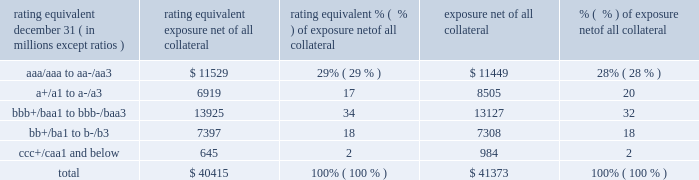Jpmorgan chase & co./2017 annual report 115 impact of wrong-way risk , which is broadly defined as the potential for increased correlation between the firm 2019s exposure to a counterparty ( avg ) and the counterparty 2019s credit quality .
Many factors may influence the nature and magnitude of these correlations over time .
To the extent that these correlations are identified , the firm may adjust the cva associated with that counterparty 2019s avg .
The firm risk manages exposure to changes in cva by entering into credit derivative transactions , as well as interest rate , foreign exchange , equity and commodity derivative transactions .
The accompanying graph shows exposure profiles to the firm 2019s current derivatives portfolio over the next 10 years as calculated by the peak , dre and avg metrics .
The three measures generally show that exposure will decline after the first year , if no new trades are added to the portfolio .
Exposure profile of derivatives measures december 31 , 2017 ( in billions ) the table summarizes the ratings profile by derivative counterparty of the firm 2019s derivative receivables , including credit derivatives , net of all collateral , at the dates indicated .
The ratings scale is based on the firm 2019s internal ratings , which generally correspond to the ratings as assigned by s&p and moody 2019s .
Ratings profile of derivative receivables .
As previously noted , the firm uses collateral agreements to mitigate counterparty credit risk .
The percentage of the firm 2019s over-the-counter derivatives transactions subject to collateral agreements 2014 excluding foreign exchange spot trades , which are not typically covered by collateral agreements due to their short maturity and centrally cleared trades that are settled daily 2014 was approximately 90% ( 90 % ) as of december 31 , 2017 , largely unchanged compared with december 31 , 2016 .
Credit derivatives the firm uses credit derivatives for two primary purposes : first , in its capacity as a market-maker , and second , as an end-user to manage the firm 2019s own credit risk associated with various exposures .
For a detailed description of credit derivatives , see credit derivatives in note 5 .
Credit portfolio management activities included in the firm 2019s end-user activities are credit derivatives used to mitigate the credit risk associated with traditional lending activities ( loans and unfunded commitments ) and derivatives counterparty exposure in the firm 2019s wholesale businesses ( collectively , 201ccredit portfolio management 201d activities ) .
Information on credit portfolio management activities is provided in the table below .
For further information on derivatives used in credit portfolio management activities , see credit derivatives in note 5 .
The firm also uses credit derivatives as an end-user to manage other exposures , including credit risk arising from certain securities held in the firm 2019s market-making businesses .
These credit derivatives are not included in credit portfolio management activities ; for further information on these credit derivatives as well as credit derivatives used in the firm 2019s capacity as a market-maker in credit derivatives , see credit derivatives in note 5 .
10 years5 years2 years1 year .
In 2017 what was the percent of the total exposure net of all collateral that was a+/a1 to a-/a3? 
Computations: (6919 / 40415)
Answer: 0.1712. Jpmorgan chase & co./2017 annual report 115 impact of wrong-way risk , which is broadly defined as the potential for increased correlation between the firm 2019s exposure to a counterparty ( avg ) and the counterparty 2019s credit quality .
Many factors may influence the nature and magnitude of these correlations over time .
To the extent that these correlations are identified , the firm may adjust the cva associated with that counterparty 2019s avg .
The firm risk manages exposure to changes in cva by entering into credit derivative transactions , as well as interest rate , foreign exchange , equity and commodity derivative transactions .
The accompanying graph shows exposure profiles to the firm 2019s current derivatives portfolio over the next 10 years as calculated by the peak , dre and avg metrics .
The three measures generally show that exposure will decline after the first year , if no new trades are added to the portfolio .
Exposure profile of derivatives measures december 31 , 2017 ( in billions ) the table summarizes the ratings profile by derivative counterparty of the firm 2019s derivative receivables , including credit derivatives , net of all collateral , at the dates indicated .
The ratings scale is based on the firm 2019s internal ratings , which generally correspond to the ratings as assigned by s&p and moody 2019s .
Ratings profile of derivative receivables .
As previously noted , the firm uses collateral agreements to mitigate counterparty credit risk .
The percentage of the firm 2019s over-the-counter derivatives transactions subject to collateral agreements 2014 excluding foreign exchange spot trades , which are not typically covered by collateral agreements due to their short maturity and centrally cleared trades that are settled daily 2014 was approximately 90% ( 90 % ) as of december 31 , 2017 , largely unchanged compared with december 31 , 2016 .
Credit derivatives the firm uses credit derivatives for two primary purposes : first , in its capacity as a market-maker , and second , as an end-user to manage the firm 2019s own credit risk associated with various exposures .
For a detailed description of credit derivatives , see credit derivatives in note 5 .
Credit portfolio management activities included in the firm 2019s end-user activities are credit derivatives used to mitigate the credit risk associated with traditional lending activities ( loans and unfunded commitments ) and derivatives counterparty exposure in the firm 2019s wholesale businesses ( collectively , 201ccredit portfolio management 201d activities ) .
Information on credit portfolio management activities is provided in the table below .
For further information on derivatives used in credit portfolio management activities , see credit derivatives in note 5 .
The firm also uses credit derivatives as an end-user to manage other exposures , including credit risk arising from certain securities held in the firm 2019s market-making businesses .
These credit derivatives are not included in credit portfolio management activities ; for further information on these credit derivatives as well as credit derivatives used in the firm 2019s capacity as a market-maker in credit derivatives , see credit derivatives in note 5 .
10 years5 years2 years1 year .
For 2016 , what percentage of derivative receivables are rated junk? 
Rationale: junk = below bbb+/baa1 to bbb-/baa3
Computations: (18 + 2)
Answer: 20.0. 